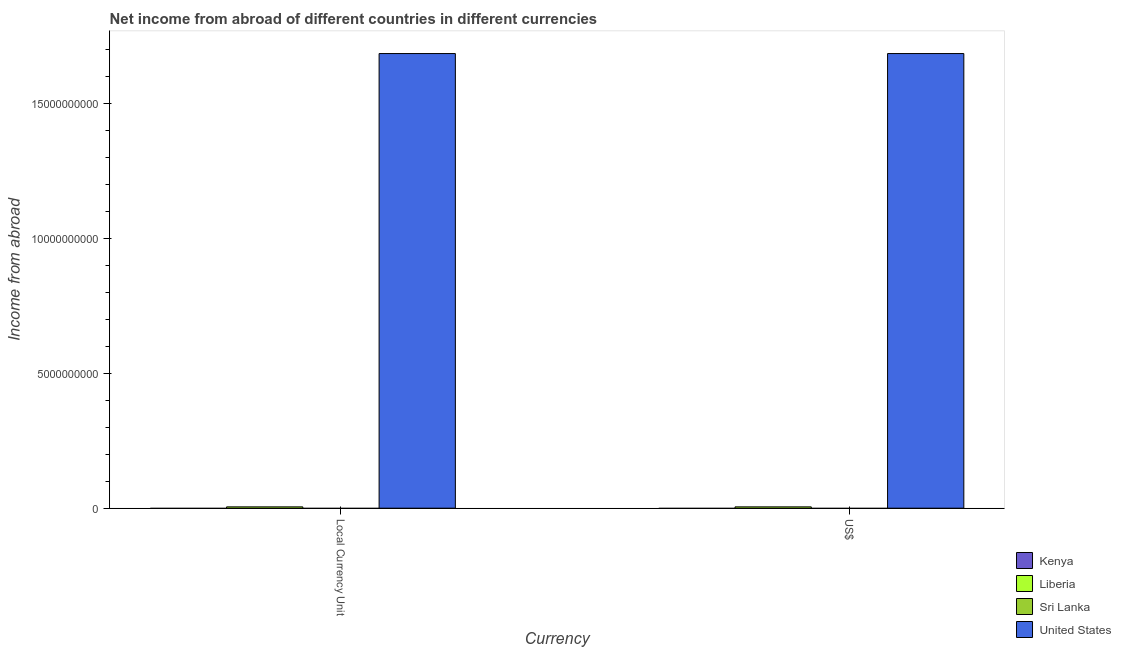How many bars are there on the 1st tick from the left?
Your answer should be compact. 2. What is the label of the 2nd group of bars from the left?
Offer a terse response. US$. What is the income from abroad in constant 2005 us$ in United States?
Ensure brevity in your answer.  1.68e+1. Across all countries, what is the maximum income from abroad in us$?
Ensure brevity in your answer.  1.68e+1. Across all countries, what is the minimum income from abroad in constant 2005 us$?
Give a very brief answer. 0. What is the total income from abroad in us$ in the graph?
Provide a short and direct response. 1.69e+1. What is the difference between the income from abroad in constant 2005 us$ in United States and that in Liberia?
Offer a very short reply. 1.68e+1. What is the difference between the income from abroad in us$ in Kenya and the income from abroad in constant 2005 us$ in United States?
Give a very brief answer. -1.68e+1. What is the average income from abroad in us$ per country?
Ensure brevity in your answer.  4.22e+09. How many bars are there?
Ensure brevity in your answer.  4. Are all the bars in the graph horizontal?
Your response must be concise. No. Does the graph contain any zero values?
Your answer should be compact. Yes. What is the title of the graph?
Make the answer very short. Net income from abroad of different countries in different currencies. Does "Bahrain" appear as one of the legend labels in the graph?
Your response must be concise. No. What is the label or title of the X-axis?
Provide a succinct answer. Currency. What is the label or title of the Y-axis?
Give a very brief answer. Income from abroad. What is the Income from abroad in Liberia in Local Currency Unit?
Make the answer very short. 4.92e+07. What is the Income from abroad of Sri Lanka in Local Currency Unit?
Give a very brief answer. 0. What is the Income from abroad in United States in Local Currency Unit?
Provide a succinct answer. 1.68e+1. What is the Income from abroad in Kenya in US$?
Your answer should be very brief. 0. What is the Income from abroad in Liberia in US$?
Provide a short and direct response. 4.92e+07. What is the Income from abroad in United States in US$?
Your response must be concise. 1.68e+1. Across all Currency, what is the maximum Income from abroad of Liberia?
Your answer should be very brief. 4.92e+07. Across all Currency, what is the maximum Income from abroad in United States?
Provide a succinct answer. 1.68e+1. Across all Currency, what is the minimum Income from abroad in Liberia?
Provide a succinct answer. 4.92e+07. Across all Currency, what is the minimum Income from abroad of United States?
Keep it short and to the point. 1.68e+1. What is the total Income from abroad in Kenya in the graph?
Provide a short and direct response. 0. What is the total Income from abroad of Liberia in the graph?
Your answer should be compact. 9.84e+07. What is the total Income from abroad of United States in the graph?
Make the answer very short. 3.37e+1. What is the difference between the Income from abroad of Liberia in Local Currency Unit and that in US$?
Offer a very short reply. 0. What is the difference between the Income from abroad in United States in Local Currency Unit and that in US$?
Your answer should be compact. 0. What is the difference between the Income from abroad in Liberia in Local Currency Unit and the Income from abroad in United States in US$?
Offer a terse response. -1.68e+1. What is the average Income from abroad of Liberia per Currency?
Provide a succinct answer. 4.92e+07. What is the average Income from abroad of Sri Lanka per Currency?
Provide a succinct answer. 0. What is the average Income from abroad of United States per Currency?
Keep it short and to the point. 1.68e+1. What is the difference between the Income from abroad of Liberia and Income from abroad of United States in Local Currency Unit?
Your answer should be very brief. -1.68e+1. What is the difference between the Income from abroad in Liberia and Income from abroad in United States in US$?
Keep it short and to the point. -1.68e+1. What is the ratio of the Income from abroad of United States in Local Currency Unit to that in US$?
Provide a short and direct response. 1. What is the difference between the highest and the second highest Income from abroad of Liberia?
Offer a terse response. 0. What is the difference between the highest and the second highest Income from abroad of United States?
Keep it short and to the point. 0. 